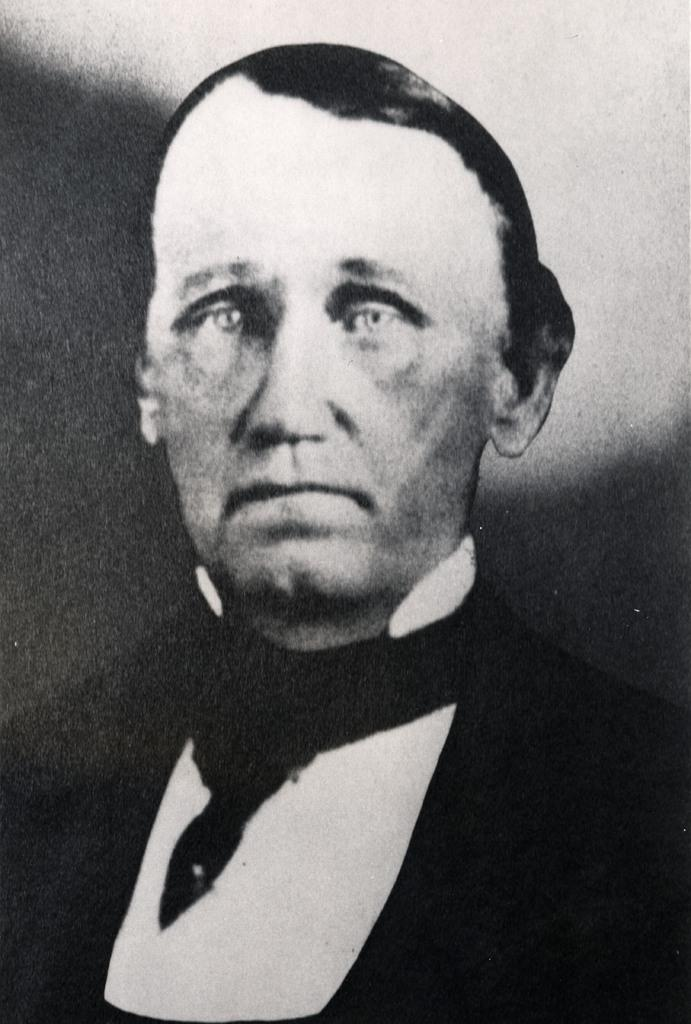What is the color scheme of the picture? The picture is black and white. Can you describe the main subject in the image? There is a man in the picture. What type of lunchroom is visible in the background of the image? There is no lunchroom present in the image; it is a black and white picture featuring a man. What discovery was made by the man in the image? There is no indication of a discovery being made in the image; it simply features a man. 